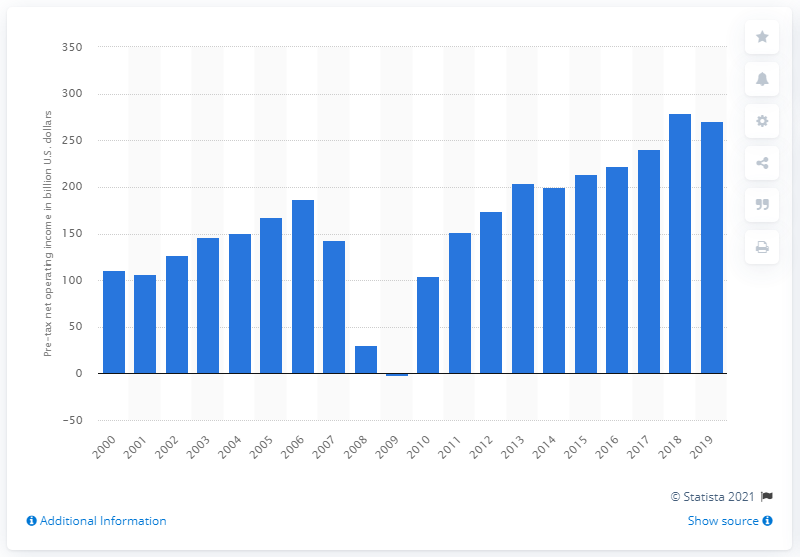Identify some key points in this picture. The net operating income of FDIC-insured commercial banks in 2019 was $270.75 million before taxes. In 2019, the pre-tax net operating income of FDIC-insured commercial banks was $270.75. 